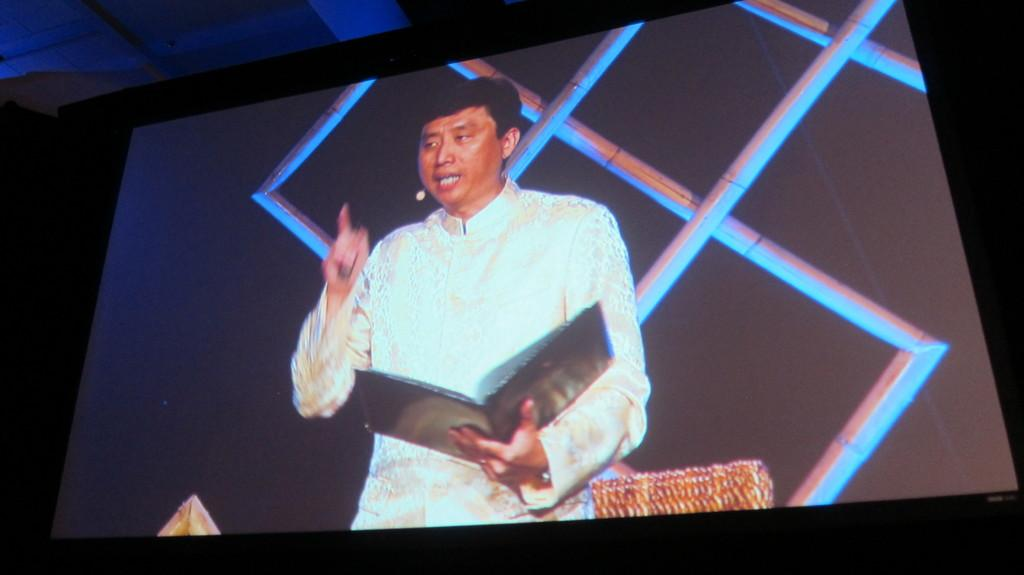What is the main subject in the center of the image? There is a screen in the center of the image. What is the person on the screen doing? The person is standing and holding a book on the screen. What can be seen in the background of the image? There is a wall and other objects visible in the background of the image. What type of duck can be seen in the background of the image? There is no duck present in the image; it only features a screen with a person holding a book and a wall with other objects in the background. 